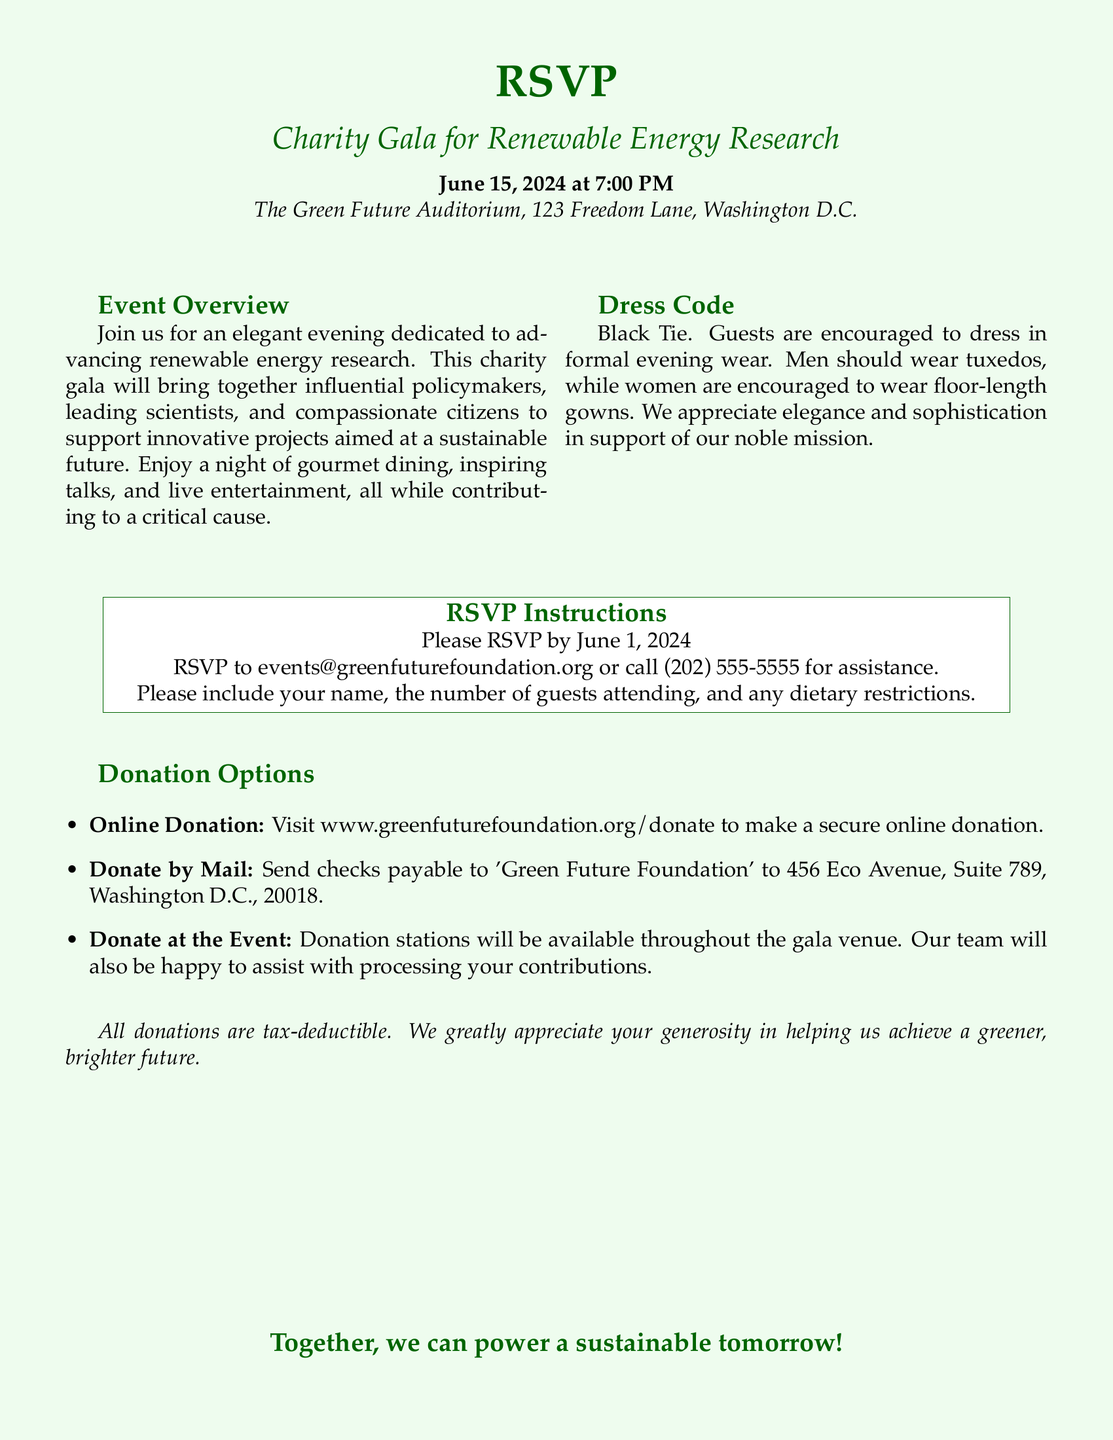What is the date of the event? The date of the event is clearly stated in the document as June 15, 2024.
Answer: June 15, 2024 What is the venue for the gala? The venue is mentioned as The Green Future Auditorium, located at 123 Freedom Lane, Washington D.C.
Answer: The Green Future Auditorium What is the dress code for the gala? The dress code is specified in the document as Black Tie.
Answer: Black Tie What is the RSVP deadline? The document states the RSVP deadline is June 1, 2024.
Answer: June 1, 2024 How can guests RSVP? Guests can RSVP by emailing or calling; the document provides the contact details for both.
Answer: events@greenfuturefoundation.org or (202) 555-5555 What types of donations are mentioned? The document outlines three methods for donations: Online Donation, Donate by Mail, and Donate at the Event.
Answer: Online Donation, Donate by Mail, Donate at the Event What should guests include in their RSVP? The document instructs guests to include their name, number of guests, and any dietary restrictions in their RSVP.
Answer: Name, number of guests, dietary restrictions Is there a tax benefit for donations? The document states that all donations are tax-deductible, indicating a tax benefit.
Answer: Yes, tax-deductible 